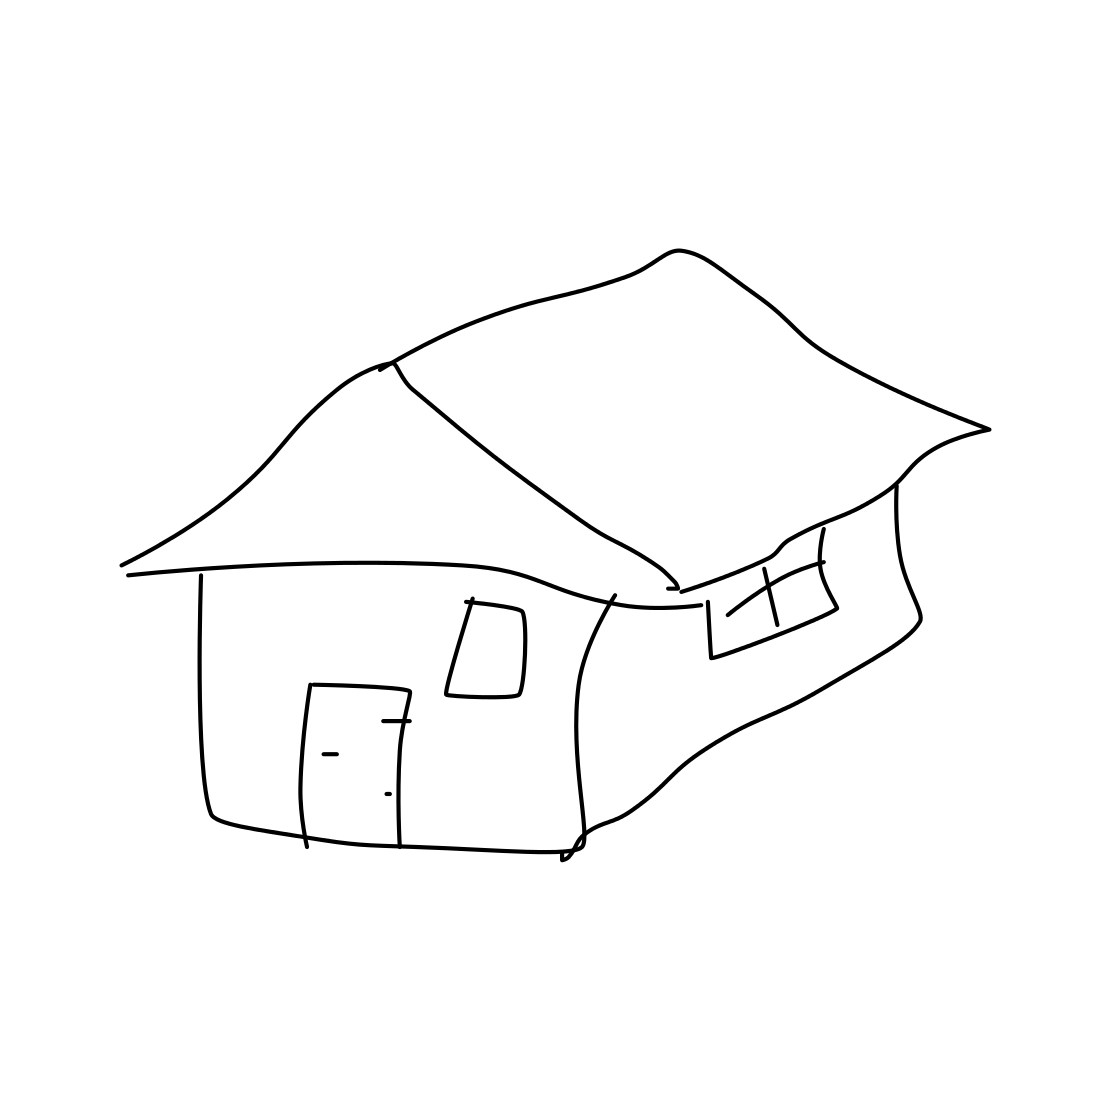Could you tell me what the weather might be like in this scenario? The image lacks environmental details that would typically indicate weather conditions. Therefore, it's open to interpretation, but the absence of rain clouds or snow leaves room to imagine a fair weather setting. Are there any signs of life or activity around the house? The drawing is quite minimalistic and does not include specific details to suggest the presence of life or activity. The house appears isolated without additional context or elements such as animals, people, or vehicles. 